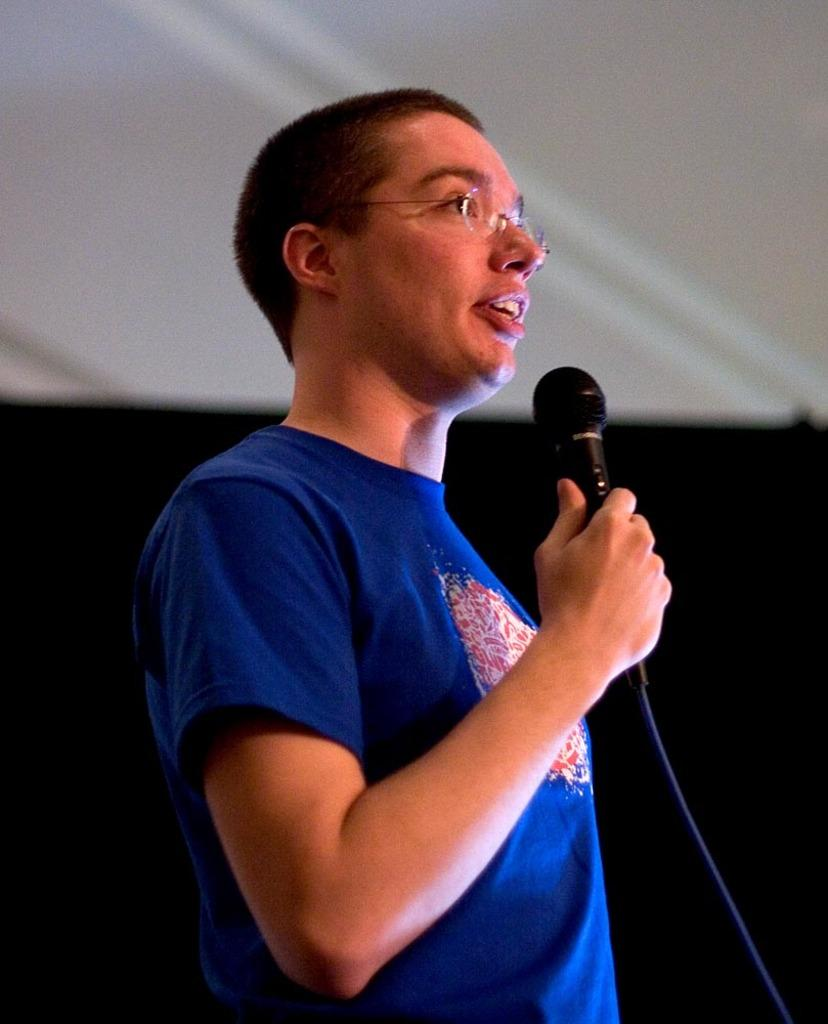Who or what is the main subject in the image? There is a person in the image. What is the person wearing? The person is wearing a blue t-shirt. What is the person holding in the image? The person is holding a microphone. How would you describe the background of the image? The background of the image is white and black in color. Can you see any bears interacting with the person in the image? No, there are no bears present in the image. Is there a ghost visible in the image? No, there is no ghost visible in the image. 